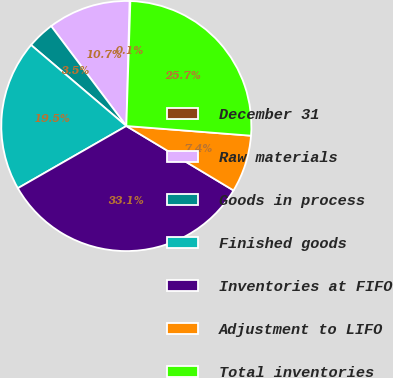Convert chart to OTSL. <chart><loc_0><loc_0><loc_500><loc_500><pie_chart><fcel>December 31<fcel>Raw materials<fcel>Goods in process<fcel>Finished goods<fcel>Inventories at FIFO<fcel>Adjustment to LIFO<fcel>Total inventories<nl><fcel>0.1%<fcel>10.68%<fcel>3.52%<fcel>19.5%<fcel>33.1%<fcel>7.38%<fcel>25.72%<nl></chart> 